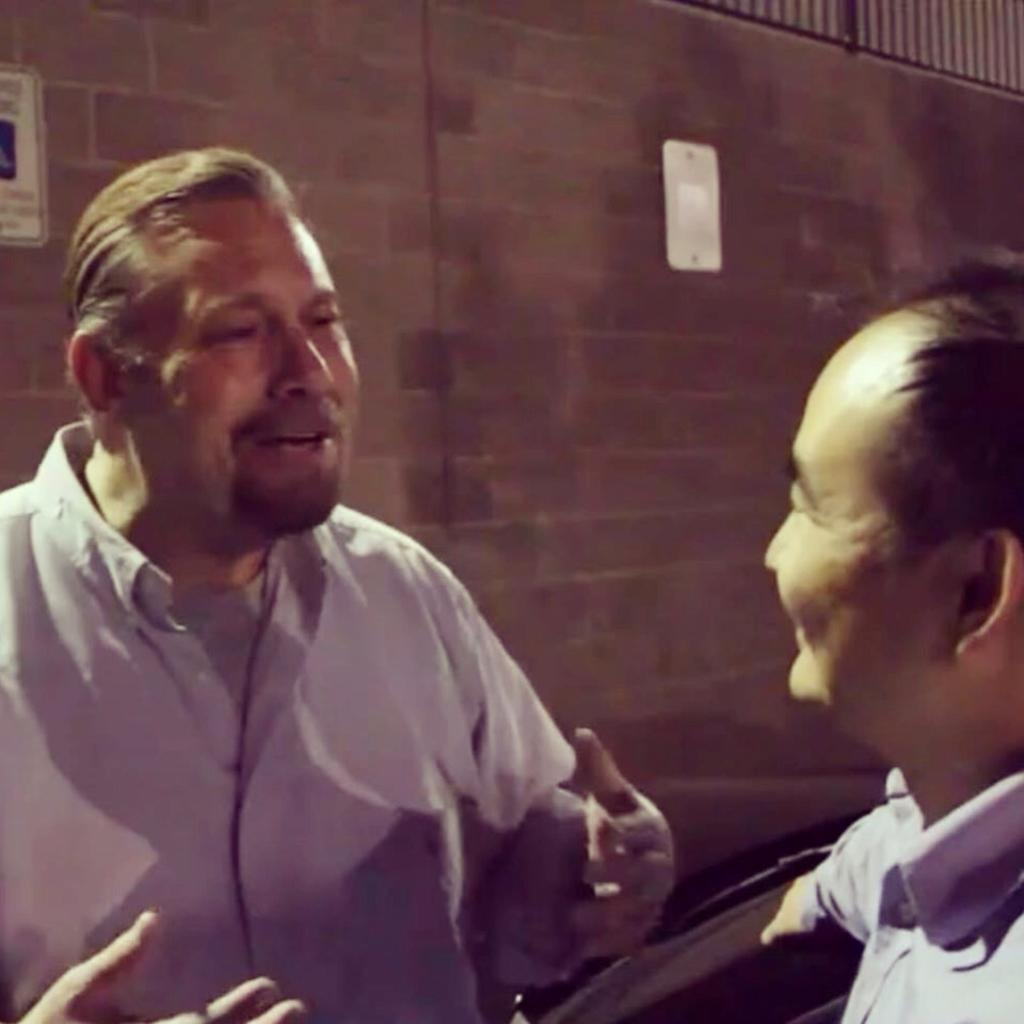How many people are in the image? There are two men in the image. What is located behind the two men? There is a wall with posters behind the two men. Can you describe the wall in the image? The wall has posters on it. What is visible at the top of the image? There is a railing at the top of the image. What type of grass can be seen growing near the cows in the image? There are no cows or grass present in the image; it features two men and a wall with posters. How many curves can be seen in the image? There are no curves visible in the image; it features a straight wall with posters and a railing. 